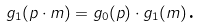Convert formula to latex. <formula><loc_0><loc_0><loc_500><loc_500>g _ { 1 } ( p \cdot m ) = g _ { 0 } ( p ) \cdot g _ { 1 } ( m ) \text {.}</formula> 